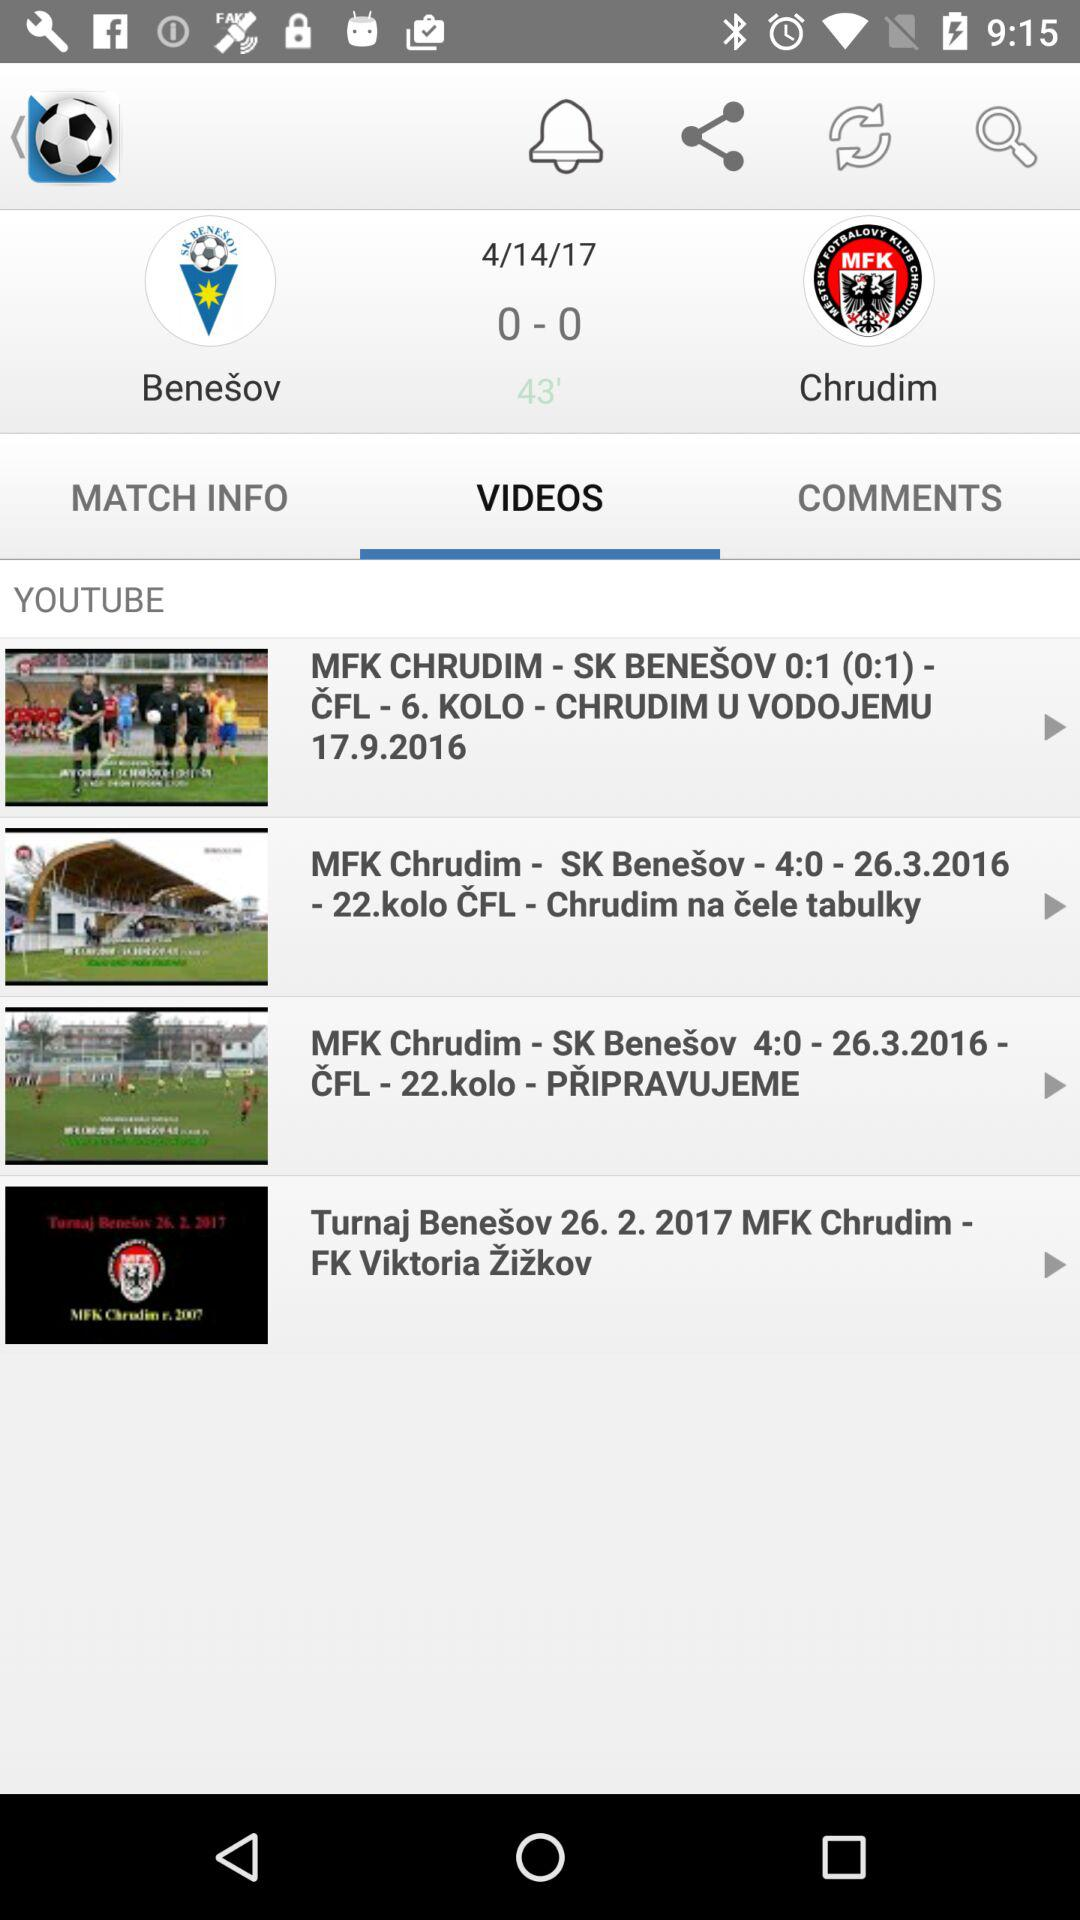How many items are in "MATCH INFO"?
When the provided information is insufficient, respond with <no answer>. <no answer> 